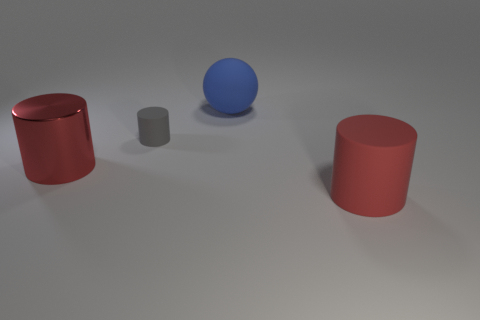Subtract all red cylinders. How many cylinders are left? 1 Add 1 small matte cubes. How many objects exist? 5 Subtract all green blocks. How many red cylinders are left? 2 Subtract all gray cylinders. How many cylinders are left? 2 Subtract 1 cylinders. How many cylinders are left? 2 Subtract 0 purple cubes. How many objects are left? 4 Subtract all balls. How many objects are left? 3 Subtract all red cylinders. Subtract all yellow cubes. How many cylinders are left? 1 Subtract all small gray shiny spheres. Subtract all large cylinders. How many objects are left? 2 Add 1 big red matte things. How many big red matte things are left? 2 